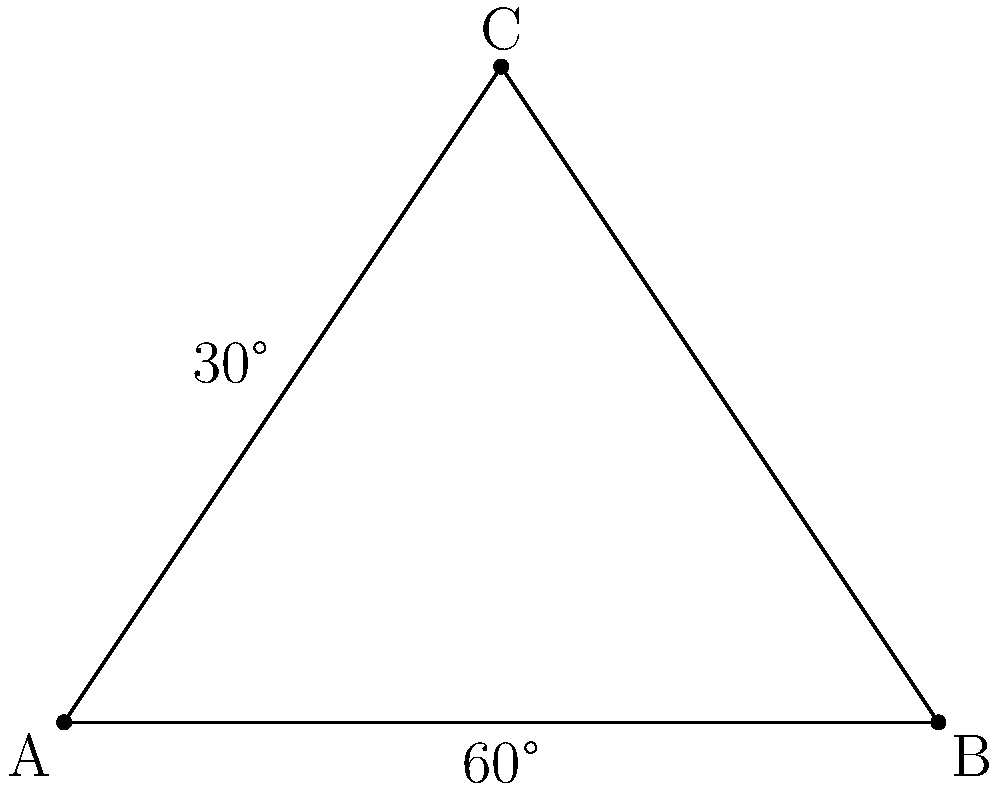In your latest geometric wall hanging, you've incorporated two wooden planks that intersect to form a triangle ABC. The angle at B measures 60°, and the angle between the height of the triangle (from C to AB) and AC is 30°. What is the measure of angle A in degrees? Let's approach this step-by-step:

1) First, let's recall that the sum of angles in a triangle is always 180°.

2) We're given that angle B is 60°.

3) The height of the triangle from C creates two right angles (90°) where it meets AB.

4) We're told that the angle between this height and AC is 30°. This means that angle C can be split into two parts: 30° and 90° - 30° = 60°.

5) So, angle C is also 60°.

6) Now we can use the fact that the sum of angles in a triangle is 180°:

   $$A + B + C = 180°$$
   $$A + 60° + 60° = 180°$$
   $$A + 120° = 180°$$
   $$A = 180° - 120° = 60°$$

Therefore, angle A is 60°.
Answer: 60° 